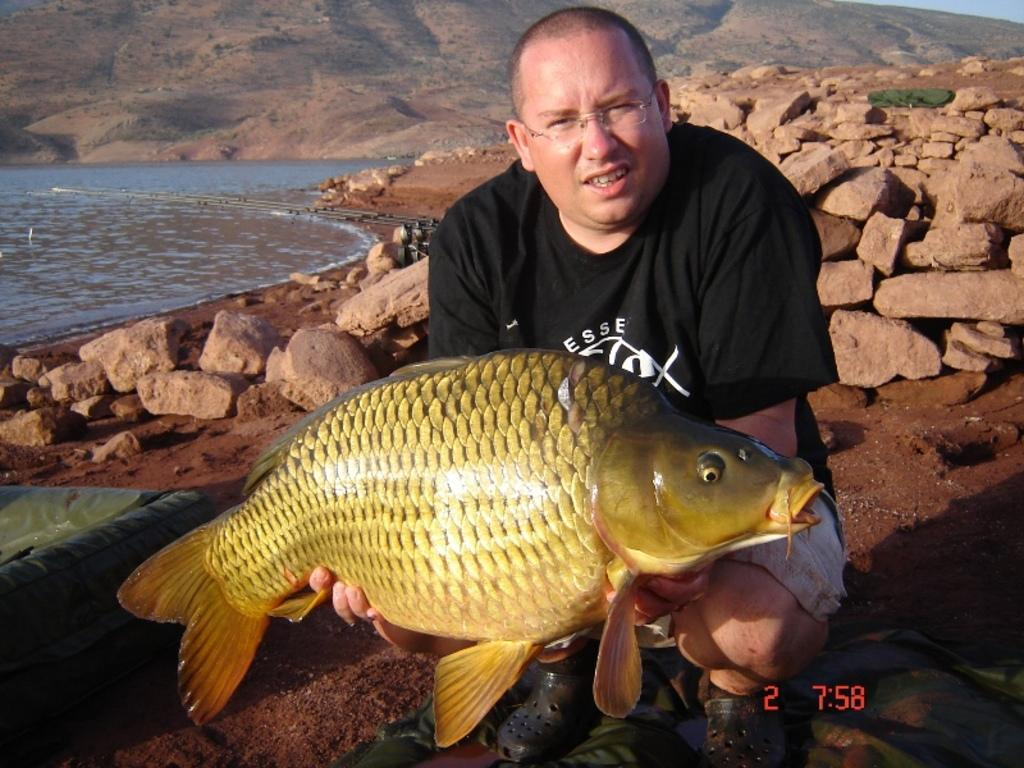What is the person in the image holding? The person is holding a fish in the image. What type of natural feature can be seen in the image? There is a mountain in the image. What is the terrain like in the image? There are rocks visible in the person in the image. What is the water source in the image? There is water visible in the image. Can you describe the unspecified objects in the image? Unfortunately, the facts provided do not give any details about the unspecified objects in the image. How many coaches are parked near the mountain in the image? There are no coaches present in the image. What type of wheel is used by the person holding the fish in the image? The person holding the fish is not using any wheels in the image. 